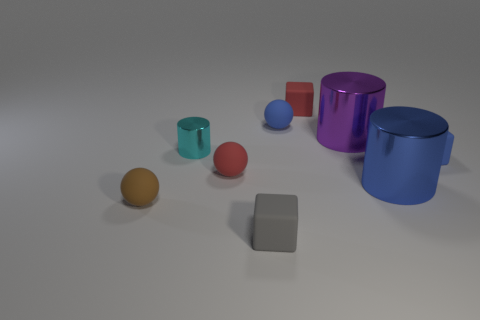Subtract all gray matte cubes. How many cubes are left? 2 Subtract all red balls. How many balls are left? 2 Subtract all balls. How many objects are left? 6 Subtract 1 blocks. How many blocks are left? 2 Add 2 tiny brown things. How many tiny brown things are left? 3 Add 8 tiny red rubber objects. How many tiny red rubber objects exist? 10 Subtract 0 green spheres. How many objects are left? 9 Subtract all cyan cylinders. Subtract all red spheres. How many cylinders are left? 2 Subtract all tiny metallic objects. Subtract all small red things. How many objects are left? 6 